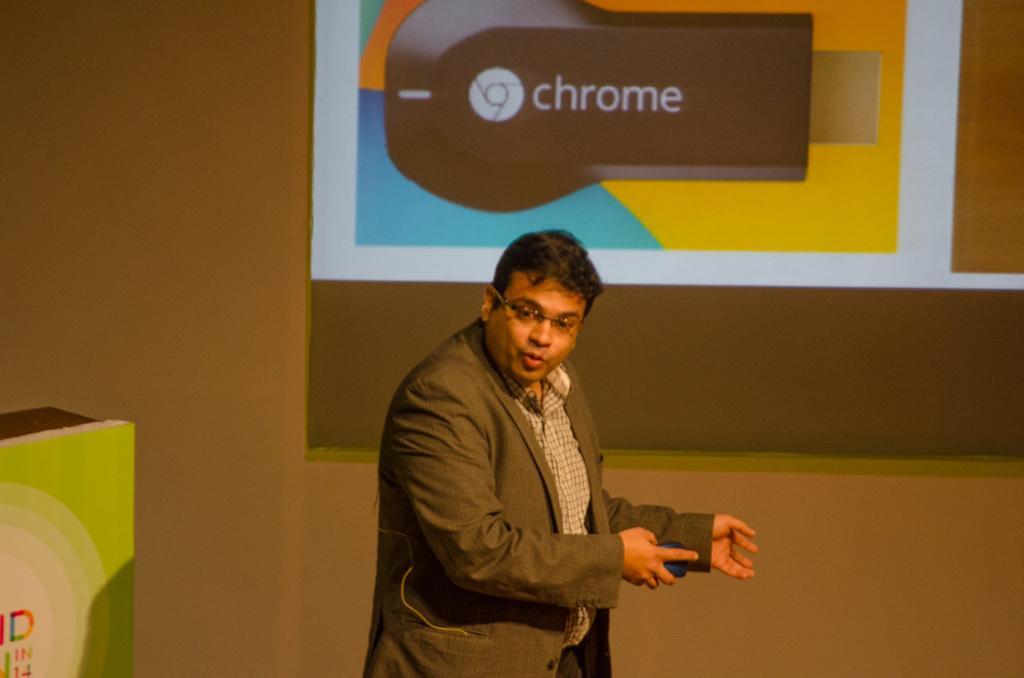In one or two sentences, can you explain what this image depicts? There is one man standing and wearing a blazer at the bottom of this image and there is a wall in the background. We can see a screen at the top of this image. 